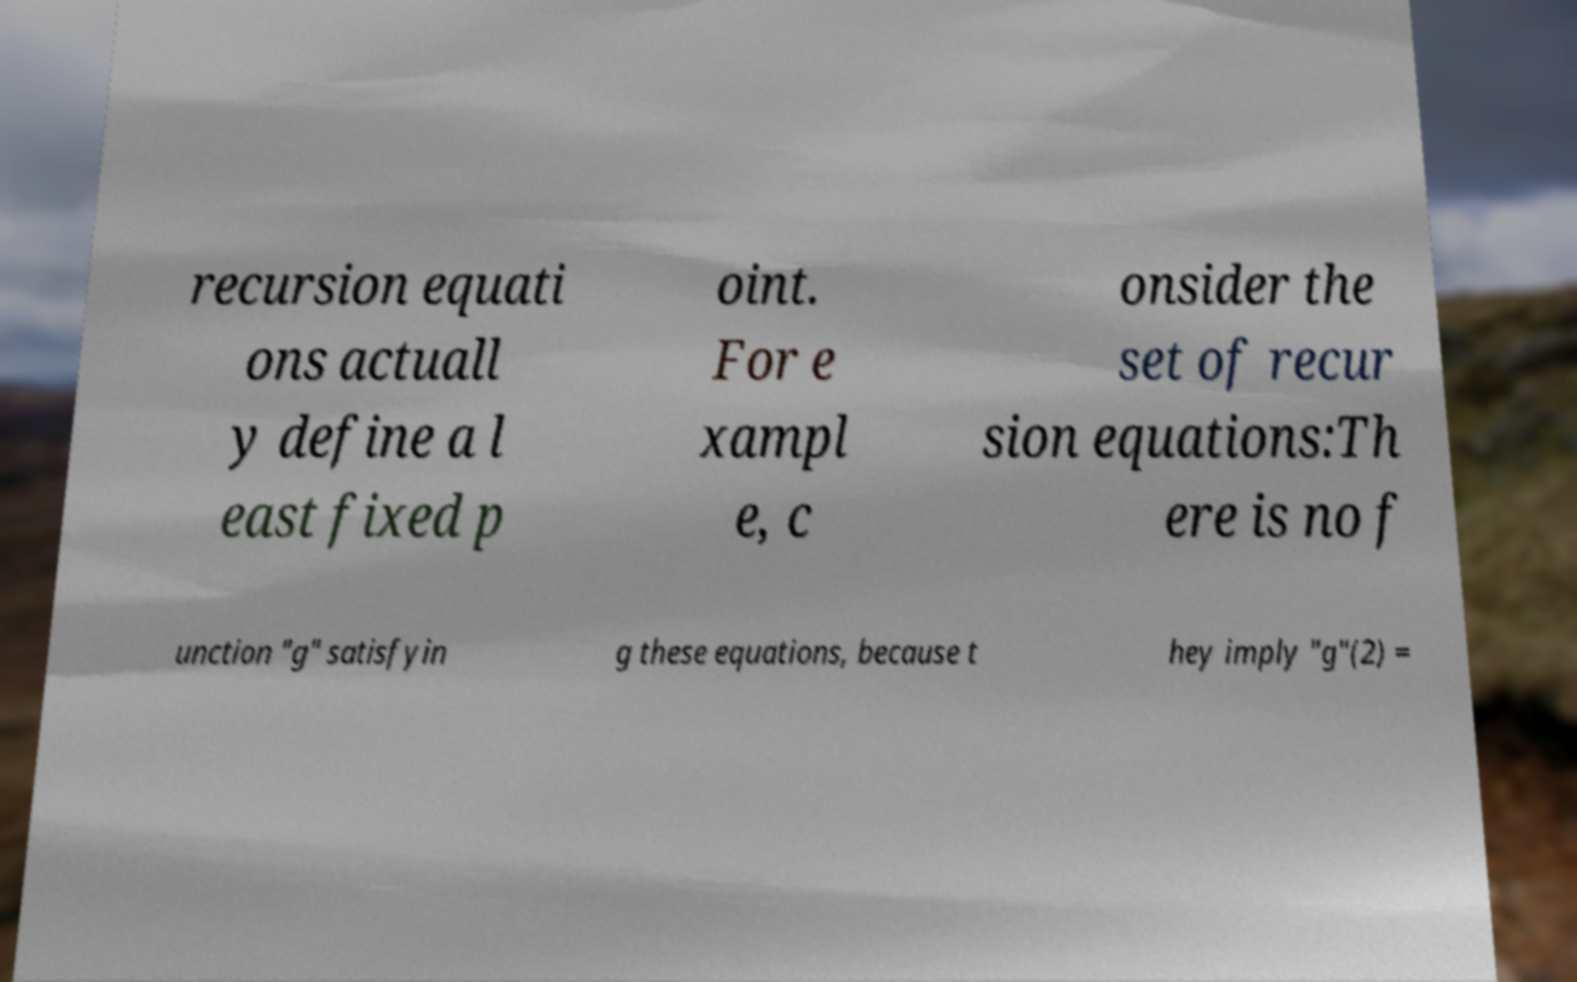I need the written content from this picture converted into text. Can you do that? recursion equati ons actuall y define a l east fixed p oint. For e xampl e, c onsider the set of recur sion equations:Th ere is no f unction "g" satisfyin g these equations, because t hey imply "g"(2) = 